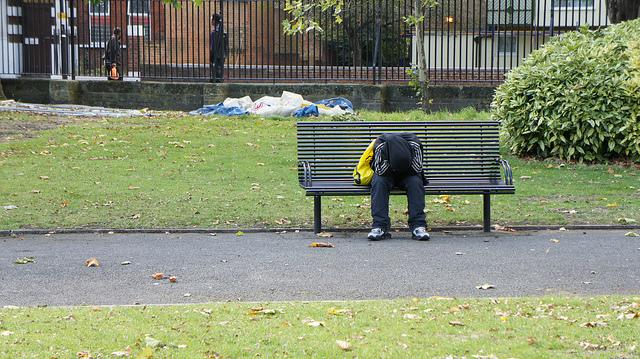Where is the head of this person? Please explain your reasoning. above knees. The person has their hood over their head.  they are sitting on the bench and they are bent over with their head resting on their legs. 